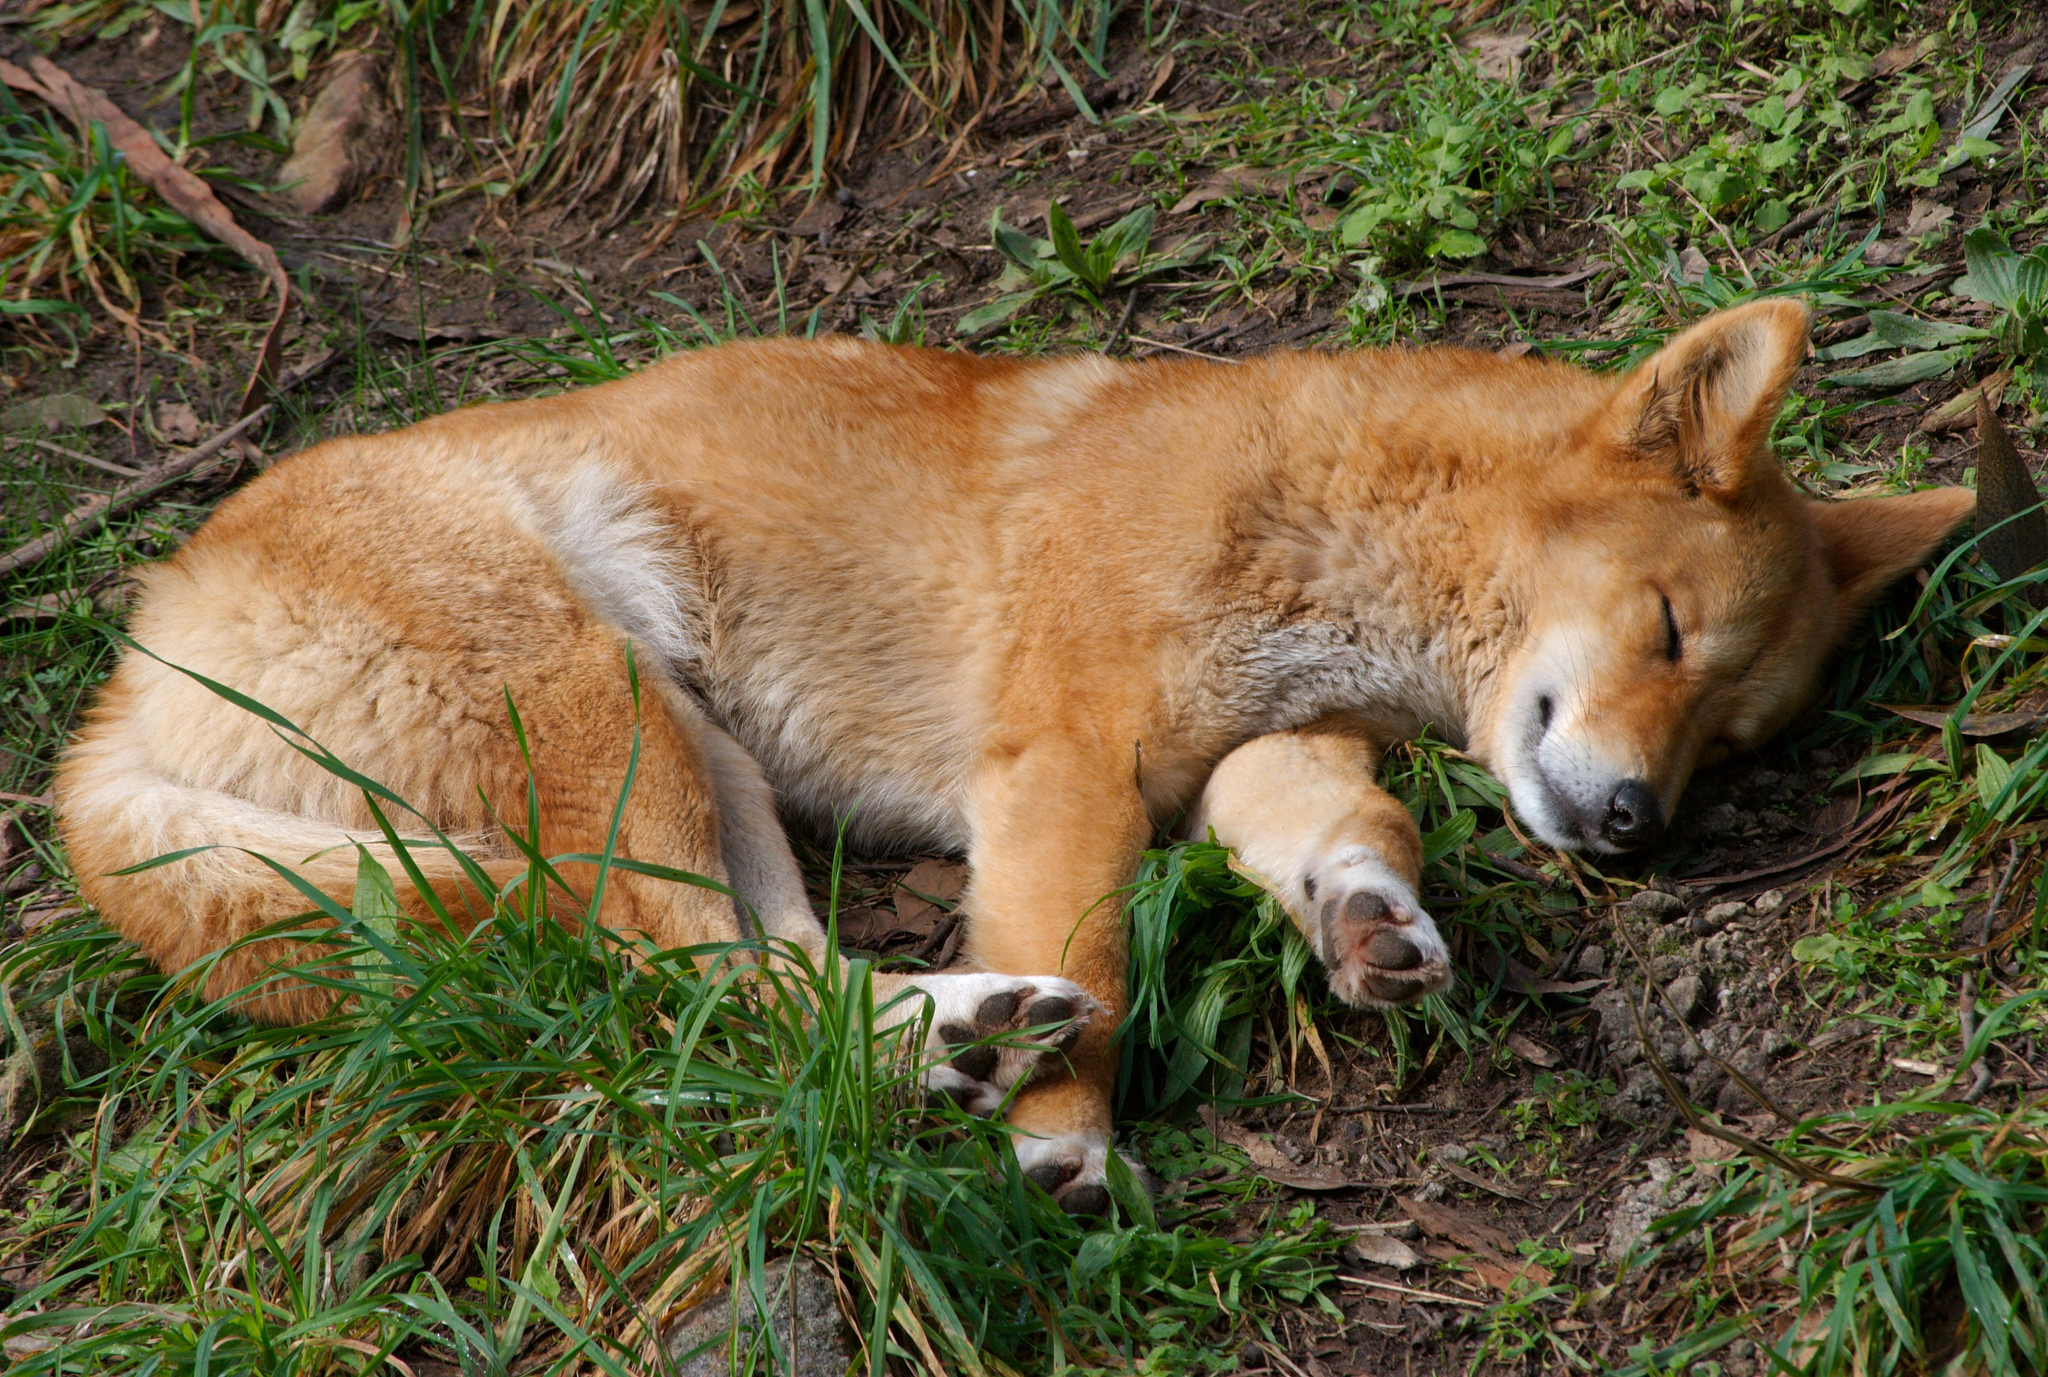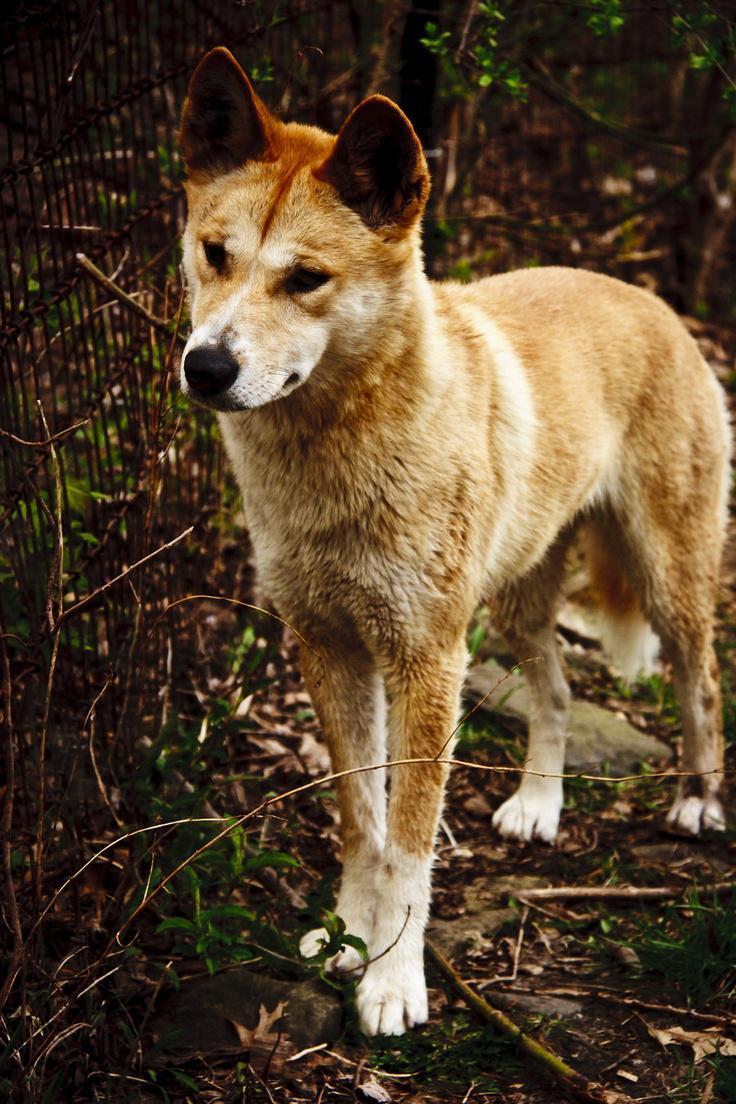The first image is the image on the left, the second image is the image on the right. Assess this claim about the two images: "Each image contains exactly one wild dog.". Correct or not? Answer yes or no. Yes. 